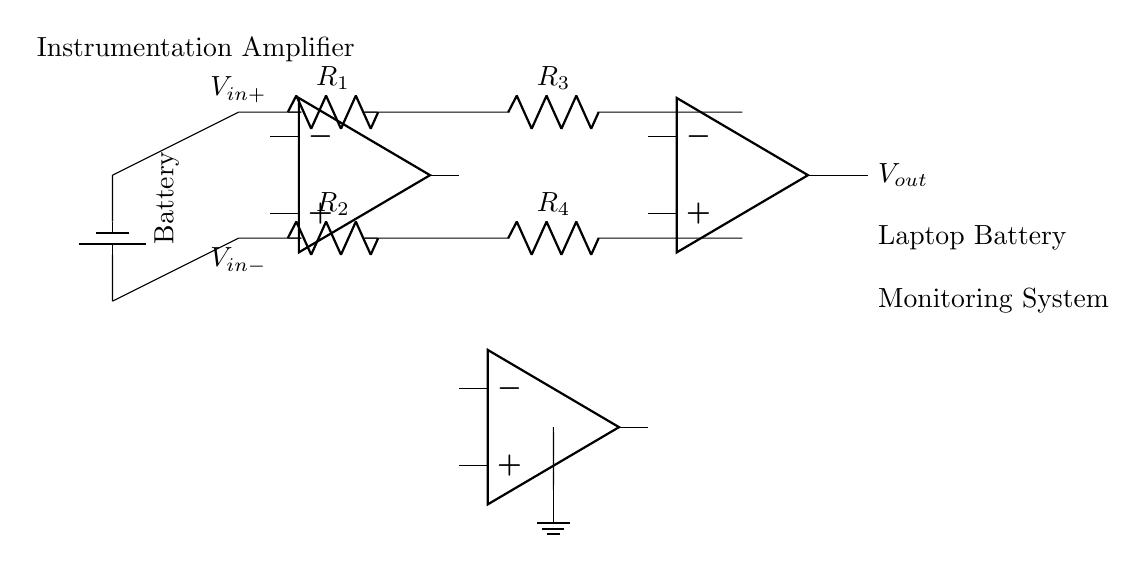What type of amplifier is shown in the circuit? The circuit depicts an instrumentation amplifier, identifiable by the configuration of op-amps and resistors designed to amplify small differential signals while rejecting noise.
Answer: instrumentation amplifier How many operational amplifiers are used in this circuit? There are three operational amplifiers present in the circuit, as indicated by the three op-amp symbols connected in the configuration.
Answer: three What do the resistors R1 and R2 represent? Resistors R1 and R2 are the input resistors, which determine the gain of the amplifier and influence how the differential input voltage is amplified.
Answer: input resistors What is the purpose of the grounding in this circuit? Grounding provides a reference point for the circuit, stabilizing the operation of the amplifier and ensuring proper functioning by establishing a common return path for the currents.
Answer: reference point What are the output and input voltage labels in this circuit? The output voltage is labeled as Vout, while the input voltages are labeled as Vin+ and Vin-, which represent the positive and negative differential inputs respectively.
Answer: Vout, Vin+, Vin- How do the feedback resistors R3 and R4 affect the gain of the amplifier? Feedback resistors R3 and R4 control the gain of the instrumentation amplifier by forming a feedback loop that allows for stable amplification of the input voltage, typically needing to be equal for accurate measurement.
Answer: control gain What is the significance of the battery in the circuit? The battery represents the power source providing electrical energy to the circuit, essential for the amplifiers and other components to operate and measure voltage in the laptop battery monitoring system.
Answer: power source 